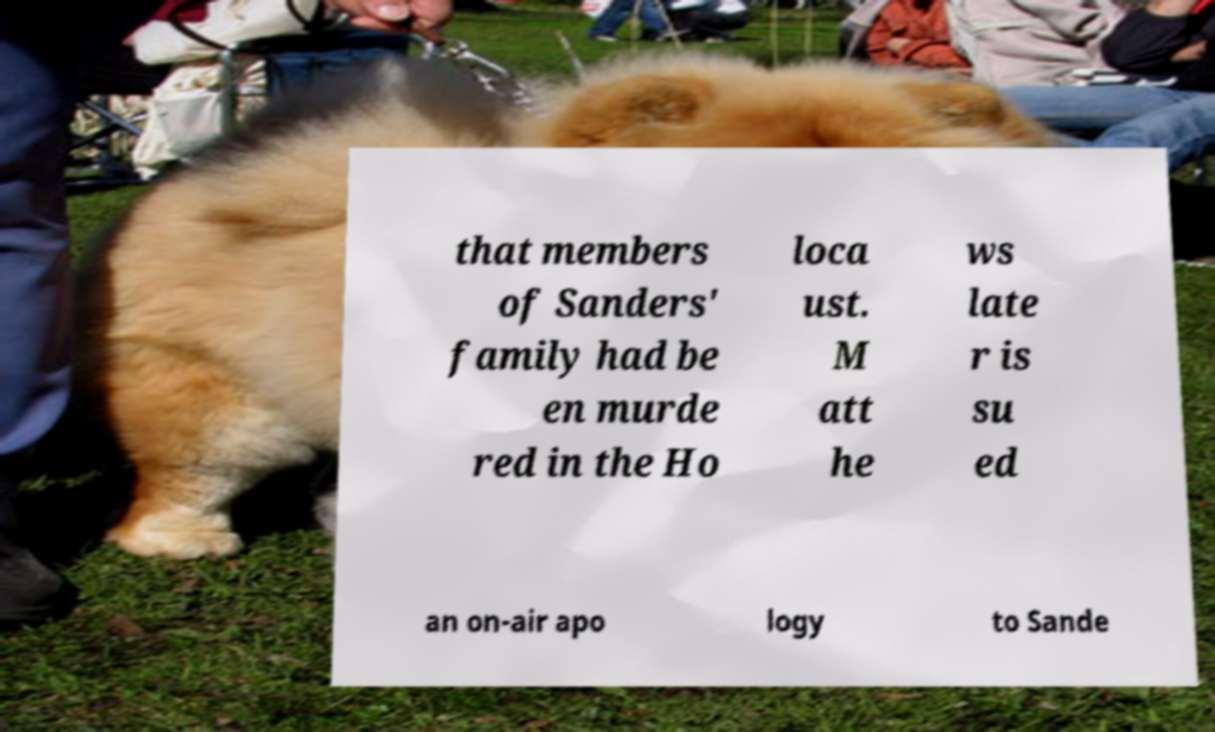I need the written content from this picture converted into text. Can you do that? that members of Sanders' family had be en murde red in the Ho loca ust. M att he ws late r is su ed an on-air apo logy to Sande 